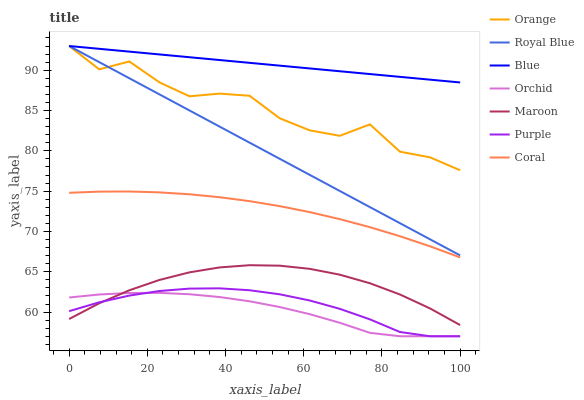Does Orchid have the minimum area under the curve?
Answer yes or no. Yes. Does Blue have the maximum area under the curve?
Answer yes or no. Yes. Does Purple have the minimum area under the curve?
Answer yes or no. No. Does Purple have the maximum area under the curve?
Answer yes or no. No. Is Blue the smoothest?
Answer yes or no. Yes. Is Orange the roughest?
Answer yes or no. Yes. Is Purple the smoothest?
Answer yes or no. No. Is Purple the roughest?
Answer yes or no. No. Does Purple have the lowest value?
Answer yes or no. Yes. Does Coral have the lowest value?
Answer yes or no. No. Does Orange have the highest value?
Answer yes or no. Yes. Does Purple have the highest value?
Answer yes or no. No. Is Purple less than Royal Blue?
Answer yes or no. Yes. Is Royal Blue greater than Purple?
Answer yes or no. Yes. Does Royal Blue intersect Blue?
Answer yes or no. Yes. Is Royal Blue less than Blue?
Answer yes or no. No. Is Royal Blue greater than Blue?
Answer yes or no. No. Does Purple intersect Royal Blue?
Answer yes or no. No. 